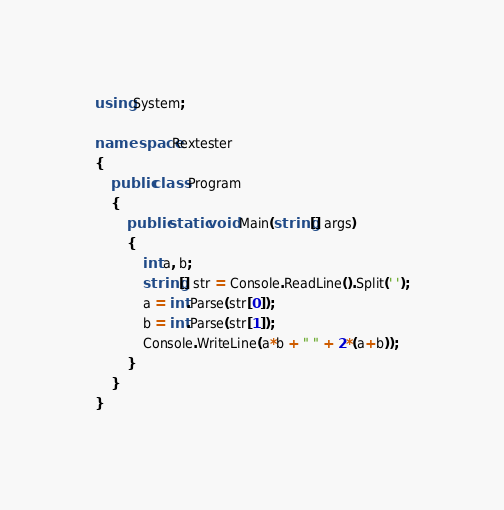<code> <loc_0><loc_0><loc_500><loc_500><_C#_>using System;

namespace Rextester
{
    public class Program
    {
        public static void Main(string[] args)
        {
            int a, b;
            string[] str = Console.ReadLine().Split(' ');
            a = int.Parse(str[0]);
            b = int.Parse(str[1]);
            Console.WriteLine(a*b + " " + 2*(a+b));
        }
    }
}

</code> 